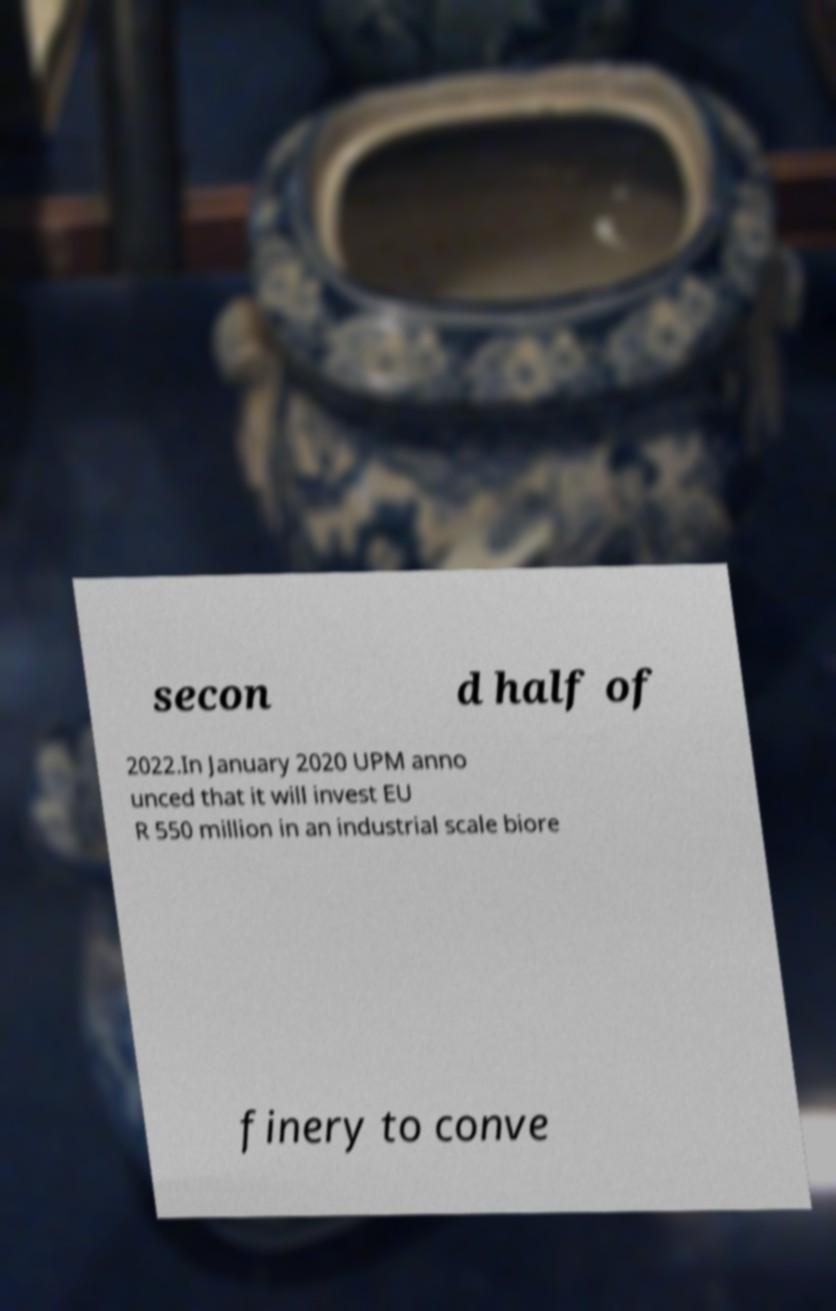There's text embedded in this image that I need extracted. Can you transcribe it verbatim? secon d half of 2022.In January 2020 UPM anno unced that it will invest EU R 550 million in an industrial scale biore finery to conve 